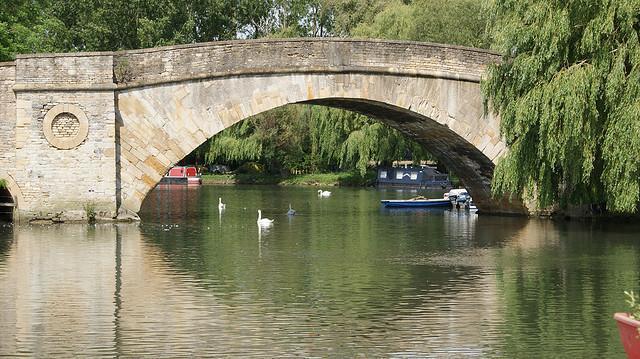How many purple backpacks are in the image?
Give a very brief answer. 0. 